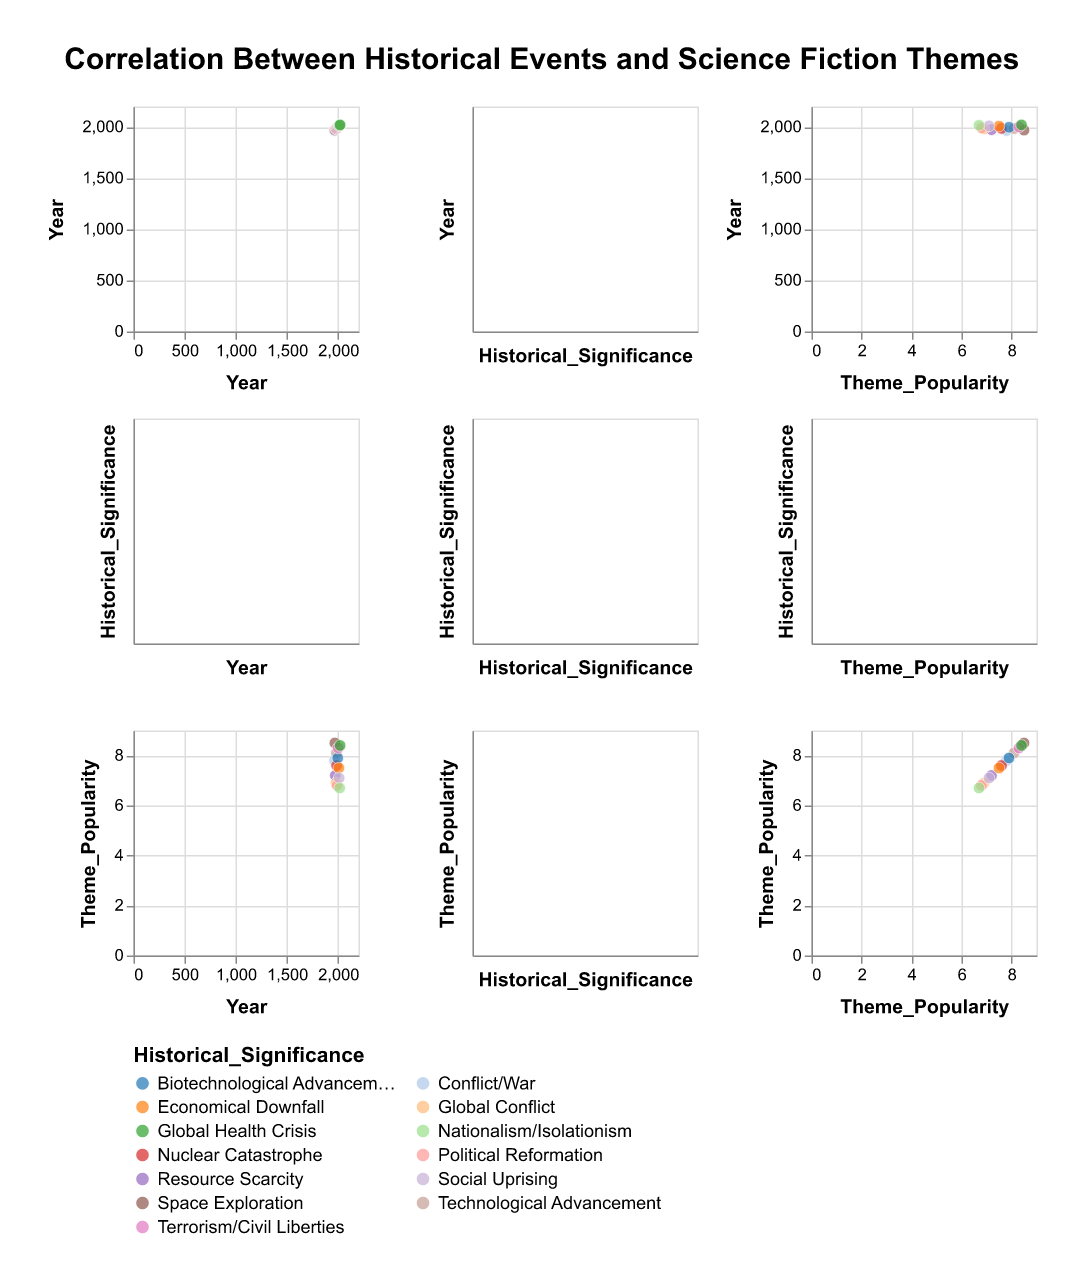What's the general trend in the popularity of science fiction themes with respect to historical significance? Looking at the SPLOM, examine the intersection of Historical_Significance and Theme_Popularity. The color legend helps identify each category of historical significance and how it spreads over the Theme_Popularity axis.
Answer: Themes related to significant technological, health, and exploration events tend to be more popular Which historical event correlates with the highest science fiction theme popularity? Examine the intersection of Year and Theme_Popularity. Look for the highest point on the Theme_Popularity axis and identify the corresponding Year and Historical_Significance.
Answer: 1969 (Moon Landing) Is there any historical event that correlates with a theme popularity below 7? Look at the data points where Theme_Popularity is less than 7 in the intersection of Year and Theme_Popularity. Confirm the associated historical events.
Answer: Yes, events in 1980 and 2016 How does the popularity of dystopian societies compare between 1965 and 2020? Observe the specific points for the years 1965 and 2020 within the Theme_Popularity axis. Compare the heights of these points.
Answer: Dystopian societies are more popular in 2020 What's the range of popularity for themes influenced by biotechnological advancements? Identify points in the intersection of Historical_Significance: Biotechnological Advancement and Theme_Popularity. Note the minimum and maximum values on the Theme_Popularity axis.
Answer: 7.9 – 7.9 Which year shows the lowest theme popularity and what historical significance is associated with it? Locate the minimum value on the Theme_Popularity axis intersection. Trace back to identify the corresponding Year and Historical_Significance.
Answer: 2016 (Nationalism/Isolationism) How do themes related to technological advancements vary in popularity over the decades? Check for historical significance categories like Technological Advancement in the SPLOM and observe their corresponding Theme_Popularity values over different years.
Answer: Generally high, notably in 1984 and 1997 Are there any clusters or groups where specific historical significances align closely with similar popularity levels? Look for areas in the SPLOM where multiple points of the same color (indicating a specific historical significance) form a noticeable cluster around certain Theme_Popularity values.
Answer: Yes, events relating to Space Exploration and Technological Advancement show clustering at higher popularity levels Which decade has the most data points with a theme popularity of over 8? Identify data points in the decades column by filtering those with Theme_Popularity values over 8. Count the points for each decade.
Answer: 2000s (2 points) 